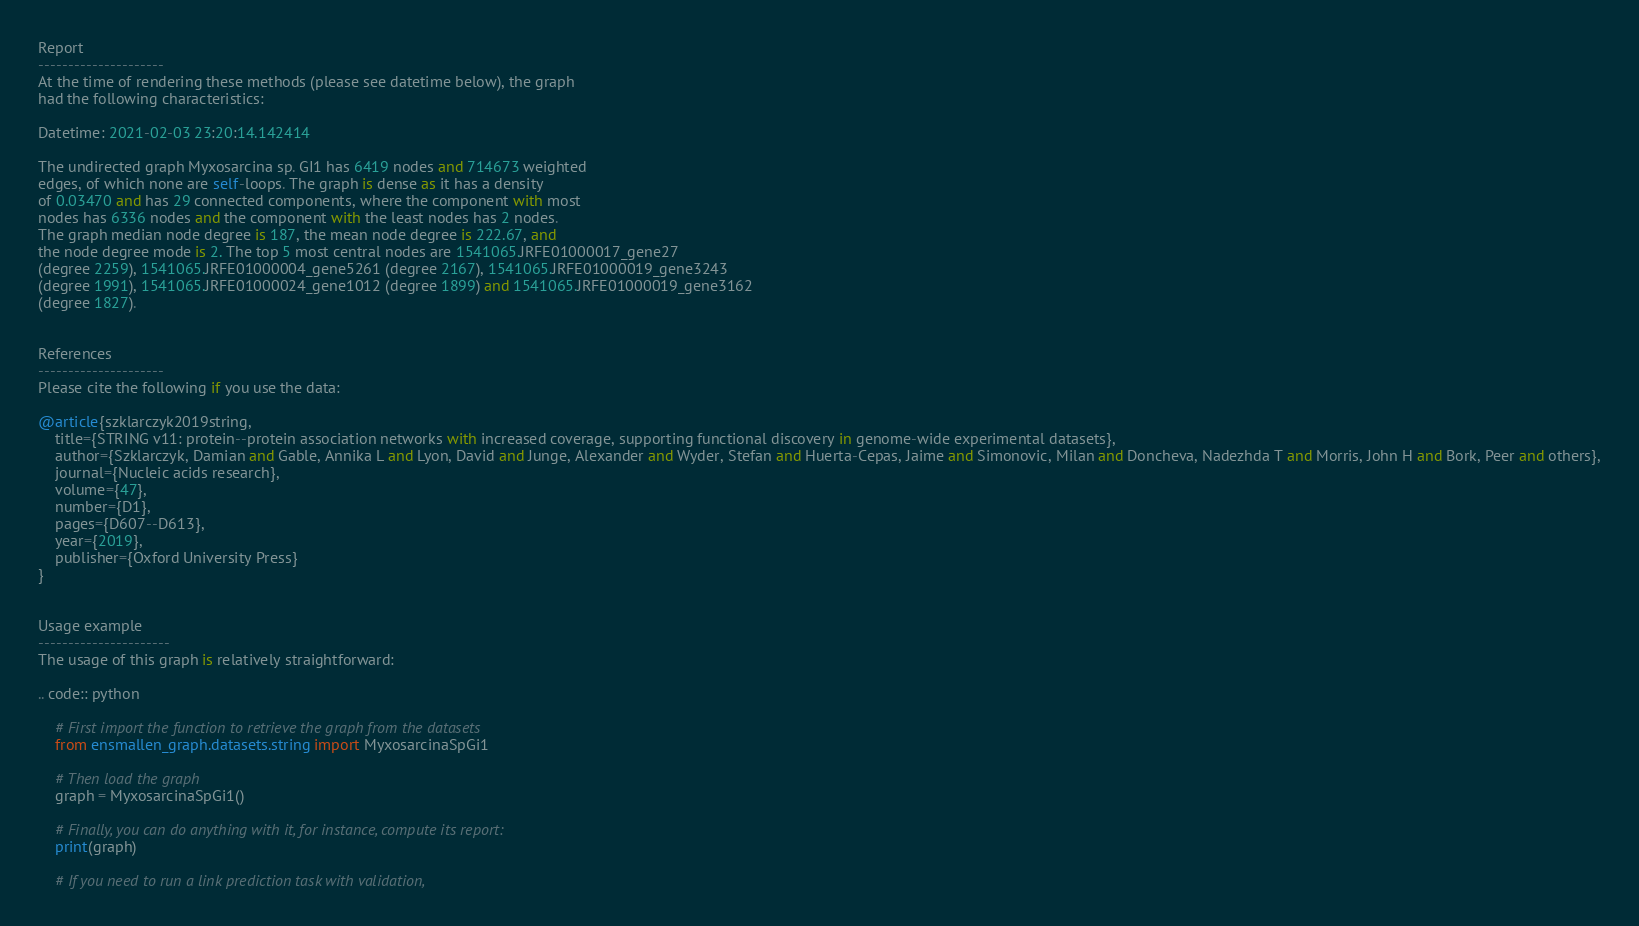Convert code to text. <code><loc_0><loc_0><loc_500><loc_500><_Python_>


Report
---------------------
At the time of rendering these methods (please see datetime below), the graph
had the following characteristics:

Datetime: 2021-02-03 23:20:14.142414

The undirected graph Myxosarcina sp. GI1 has 6419 nodes and 714673 weighted
edges, of which none are self-loops. The graph is dense as it has a density
of 0.03470 and has 29 connected components, where the component with most
nodes has 6336 nodes and the component with the least nodes has 2 nodes.
The graph median node degree is 187, the mean node degree is 222.67, and
the node degree mode is 2. The top 5 most central nodes are 1541065.JRFE01000017_gene27
(degree 2259), 1541065.JRFE01000004_gene5261 (degree 2167), 1541065.JRFE01000019_gene3243
(degree 1991), 1541065.JRFE01000024_gene1012 (degree 1899) and 1541065.JRFE01000019_gene3162
(degree 1827).


References
---------------------
Please cite the following if you use the data:

@article{szklarczyk2019string,
    title={STRING v11: protein--protein association networks with increased coverage, supporting functional discovery in genome-wide experimental datasets},
    author={Szklarczyk, Damian and Gable, Annika L and Lyon, David and Junge, Alexander and Wyder, Stefan and Huerta-Cepas, Jaime and Simonovic, Milan and Doncheva, Nadezhda T and Morris, John H and Bork, Peer and others},
    journal={Nucleic acids research},
    volume={47},
    number={D1},
    pages={D607--D613},
    year={2019},
    publisher={Oxford University Press}
}


Usage example
----------------------
The usage of this graph is relatively straightforward:

.. code:: python

    # First import the function to retrieve the graph from the datasets
    from ensmallen_graph.datasets.string import MyxosarcinaSpGi1

    # Then load the graph
    graph = MyxosarcinaSpGi1()

    # Finally, you can do anything with it, for instance, compute its report:
    print(graph)

    # If you need to run a link prediction task with validation,</code> 